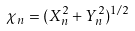<formula> <loc_0><loc_0><loc_500><loc_500>\chi _ { n } = ( X _ { n } ^ { 2 } + Y _ { n } ^ { 2 } ) ^ { 1 / 2 }</formula> 